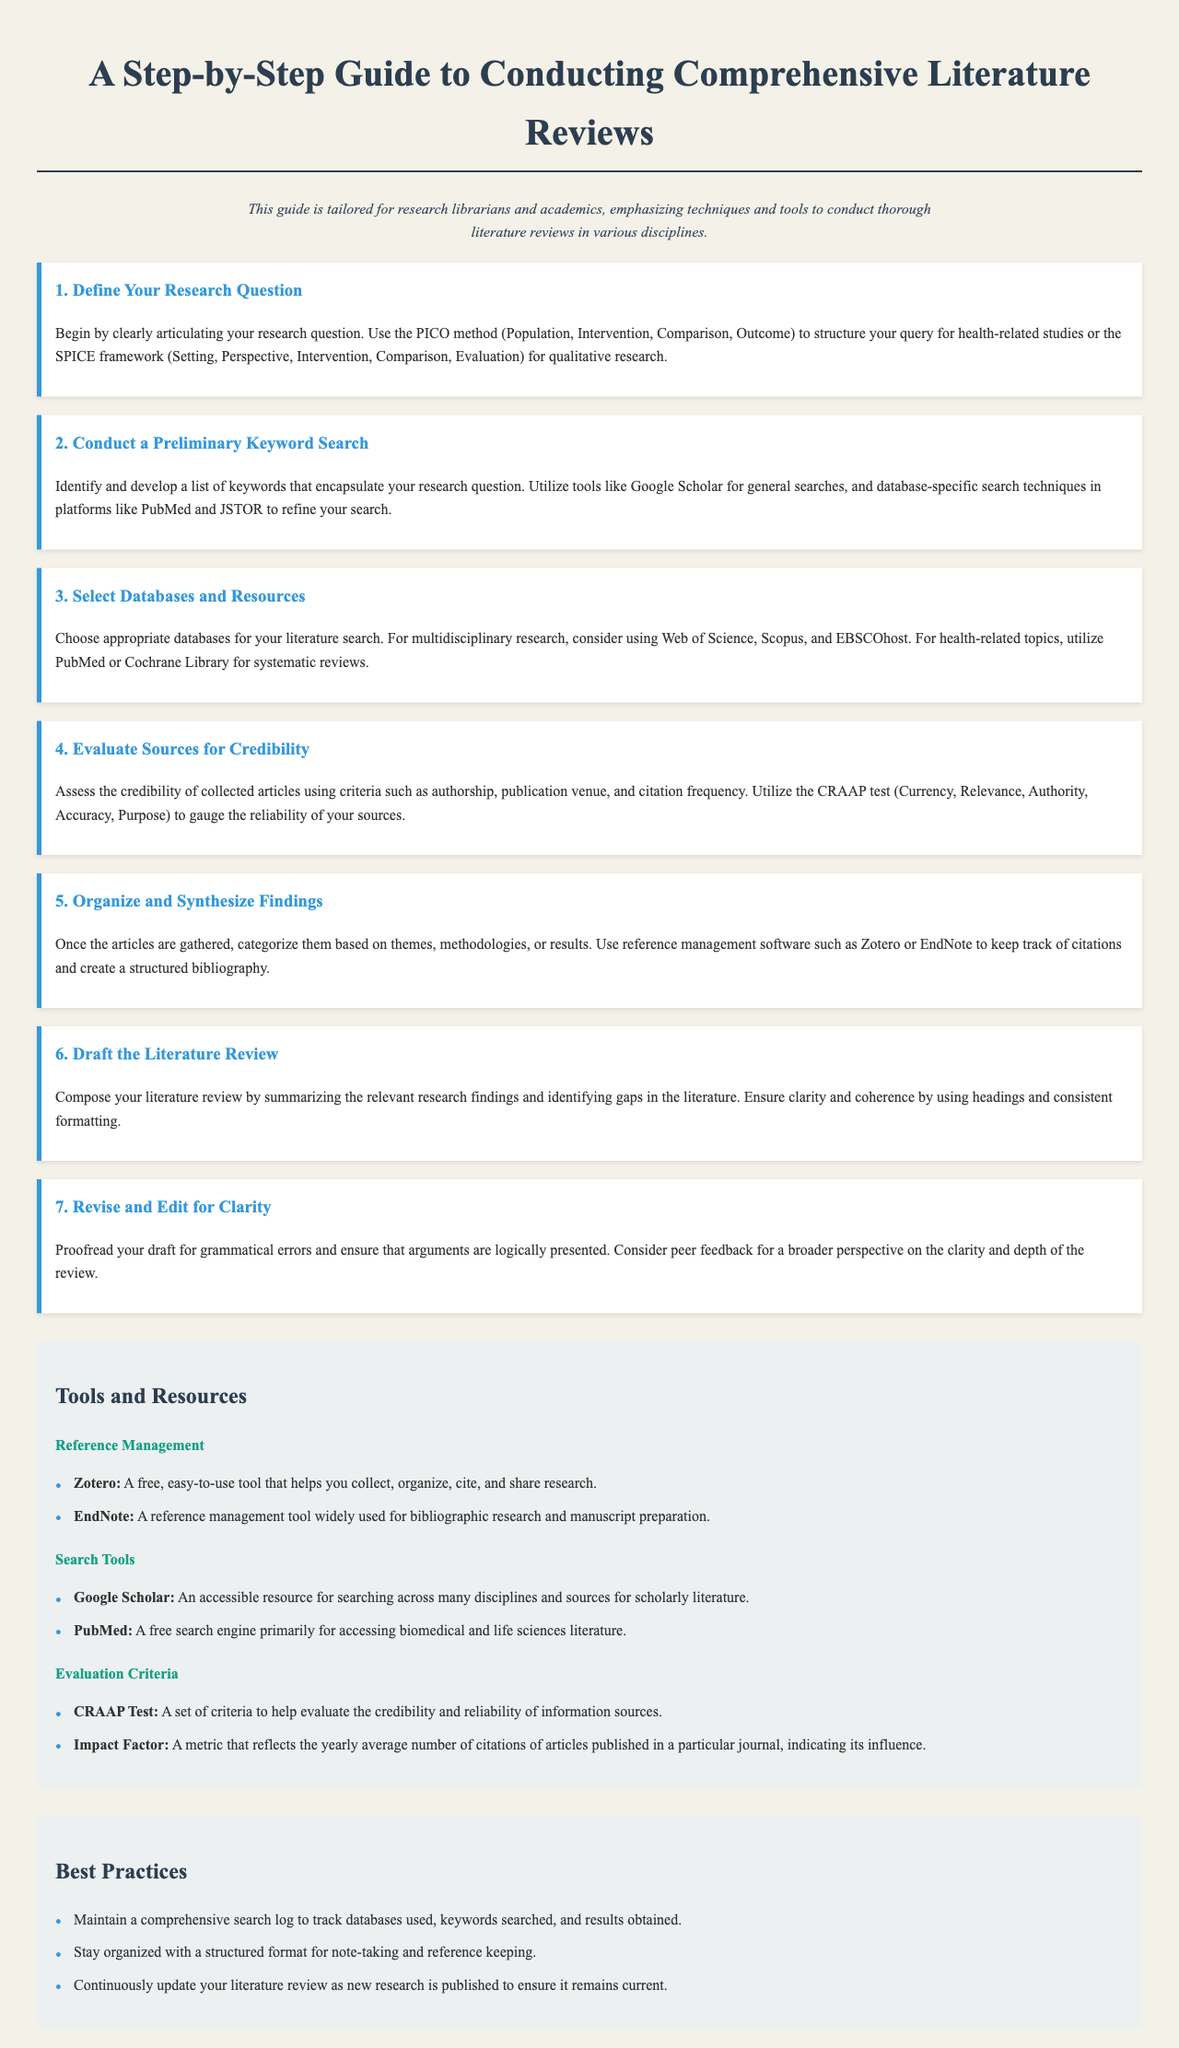What is the first step in conducting a literature review? The first step outlined in the guide is to define your research question.
Answer: Define Your Research Question Which database is recommended for multidisciplinary research? The guide suggests Web of Science for multidisciplinary research.
Answer: Web of Science What evaluation criteria is mentioned to assess source credibility? The CRAAP test is mentioned as a criteria to gauge the reliability of sources.
Answer: CRAAP test How many steps are involved in the literature review process? The guide details a total of seven steps in the literature review process.
Answer: Seven What tool is recommended for reference management? Zotero is recommended as a free tool for managing references.
Answer: Zotero What is a suggested best practice for literature reviews? Maintaining a comprehensive search log is a suggested best practice.
Answer: Comprehensive search log Which method is suggested for crafting research questions in health studies? The PICO method is suggested for structuring queries in health-related studies.
Answer: PICO method Which search tool is specifically for biomedical literature? PubMed is identified as a search tool primarily for accessing biomedical literature.
Answer: PubMed 